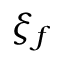Convert formula to latex. <formula><loc_0><loc_0><loc_500><loc_500>\xi _ { f }</formula> 